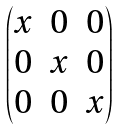Convert formula to latex. <formula><loc_0><loc_0><loc_500><loc_500>\begin{pmatrix} x & 0 & 0 \\ 0 & x & 0 \\ 0 & 0 & x \\ \end{pmatrix}</formula> 